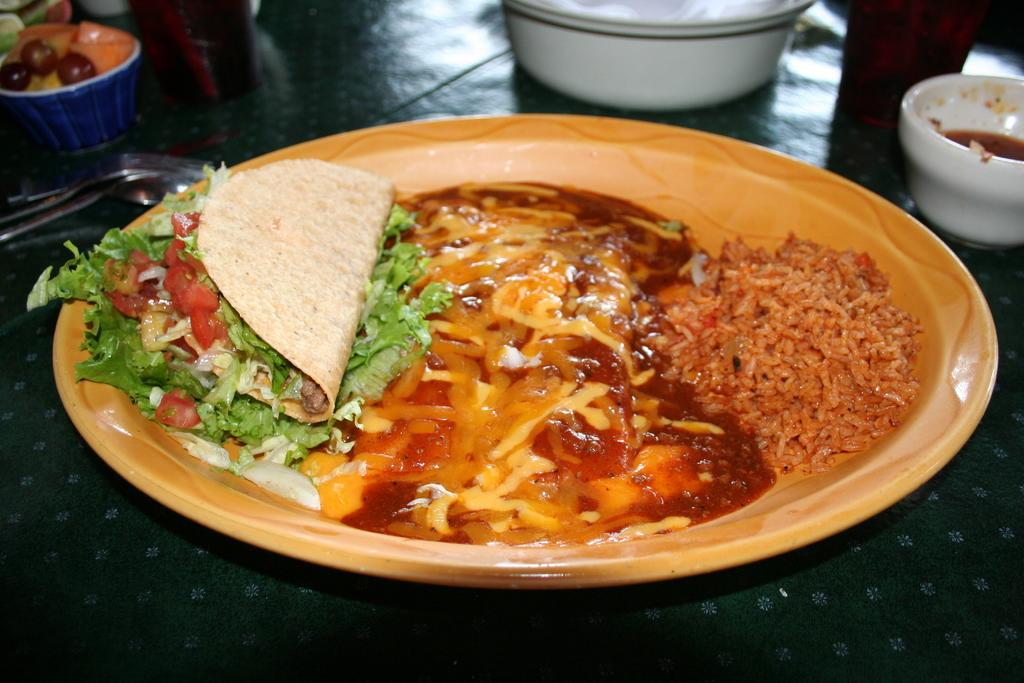What is on the plate that is visible in the image? There is a plate containing food in the image. What else can be seen in the image besides the plate? There are bowls visible in the image. What objects are on the floor in the image? There are spoons visible on the floor in the image. Where is the drawer located in the image? There is no drawer present in the image. What type of plantation can be seen in the image? There is no plantation present in the image. 